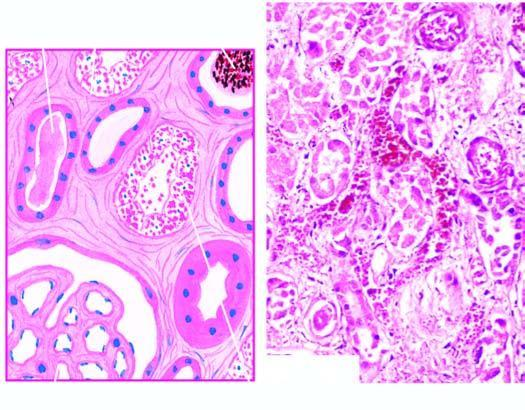s sectioned slice of the liver focal necrosis along the nephron involving proximal convoluted tubule as well as distal convoluted tubule dct?
Answer the question using a single word or phrase. No 